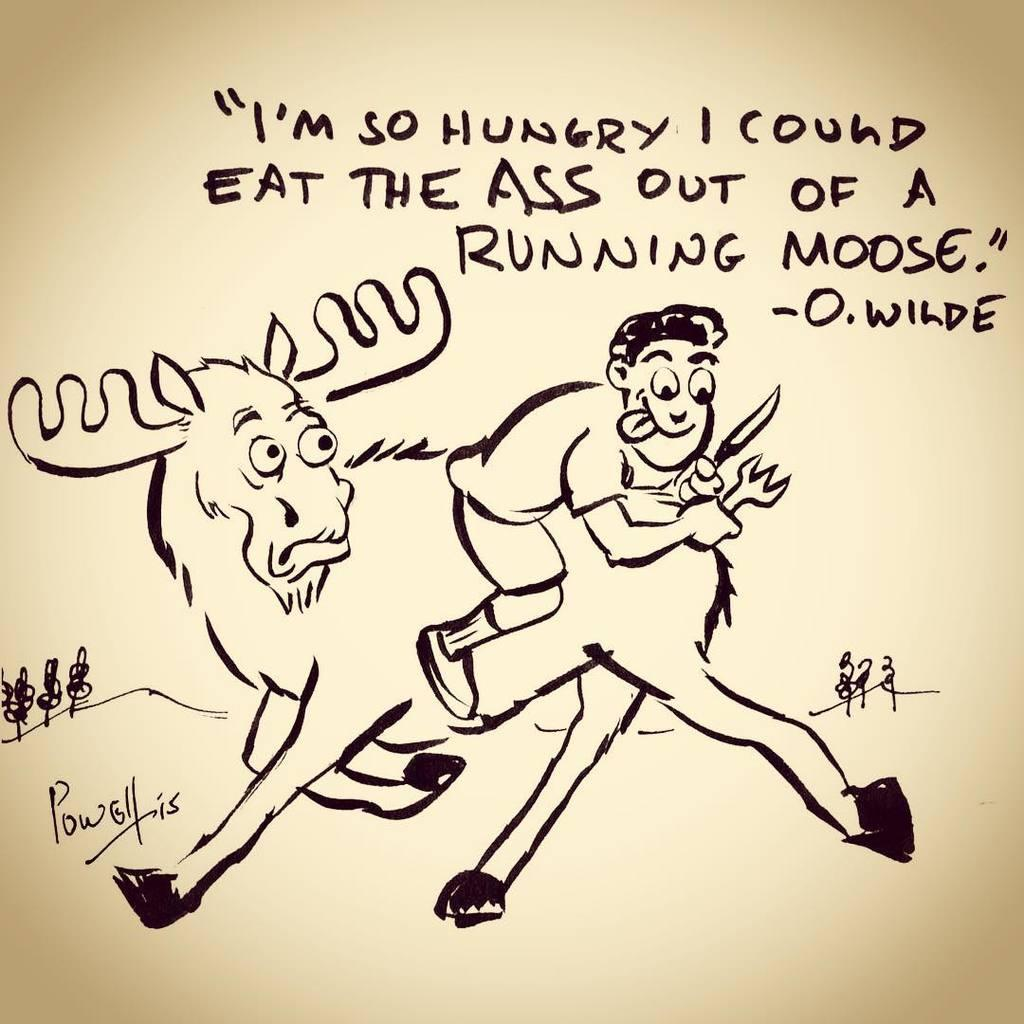What type of animal is depicted in the drawing in the image? There is a drawing of a donkey in the image. Who else is depicted in the drawing? There is a drawing of a man in the image. Are there any words or letters on the drawing? Yes, there is text written on the drawing. What type of alley can be seen in the background of the drawing? There is no alley present in the image, as it is a drawing of a donkey and a man with text written on it. 